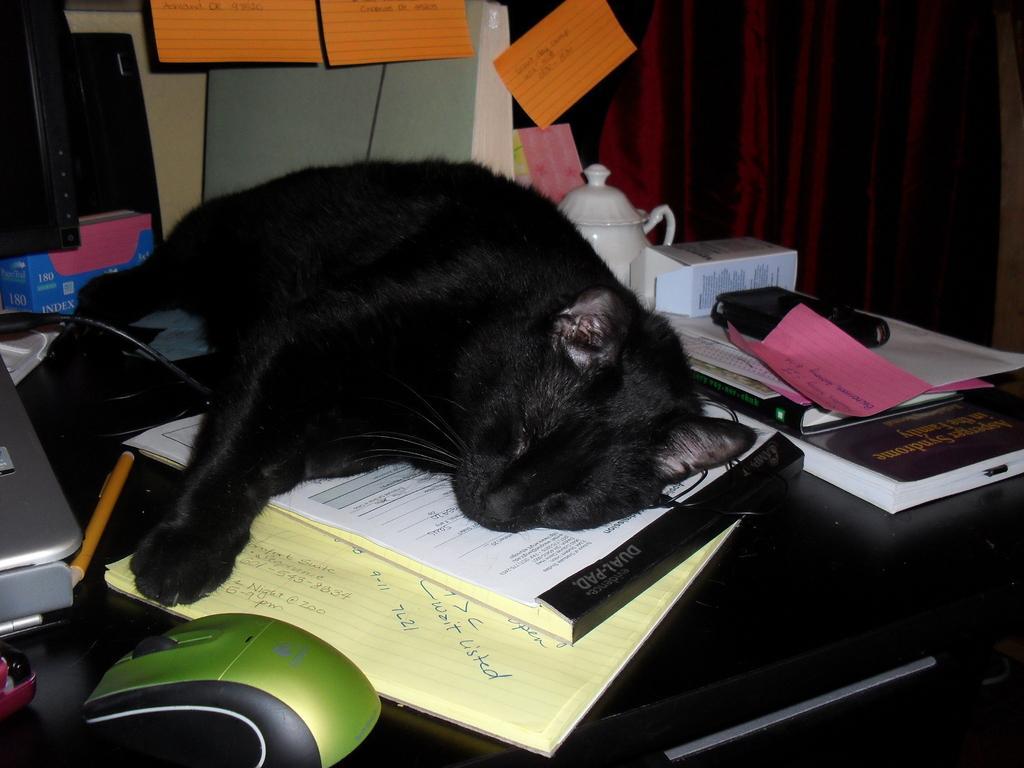Could you give a brief overview of what you see in this image? In this picture, we see a black table on which books, glass jar, laptop, pen, mouse, monitor and boxes are placed. We see a black cat is sleeping on the table. Behind that, we see posters and charts are pasted on the wall. On the right side, we see a wall or a sheet in maroon color. 